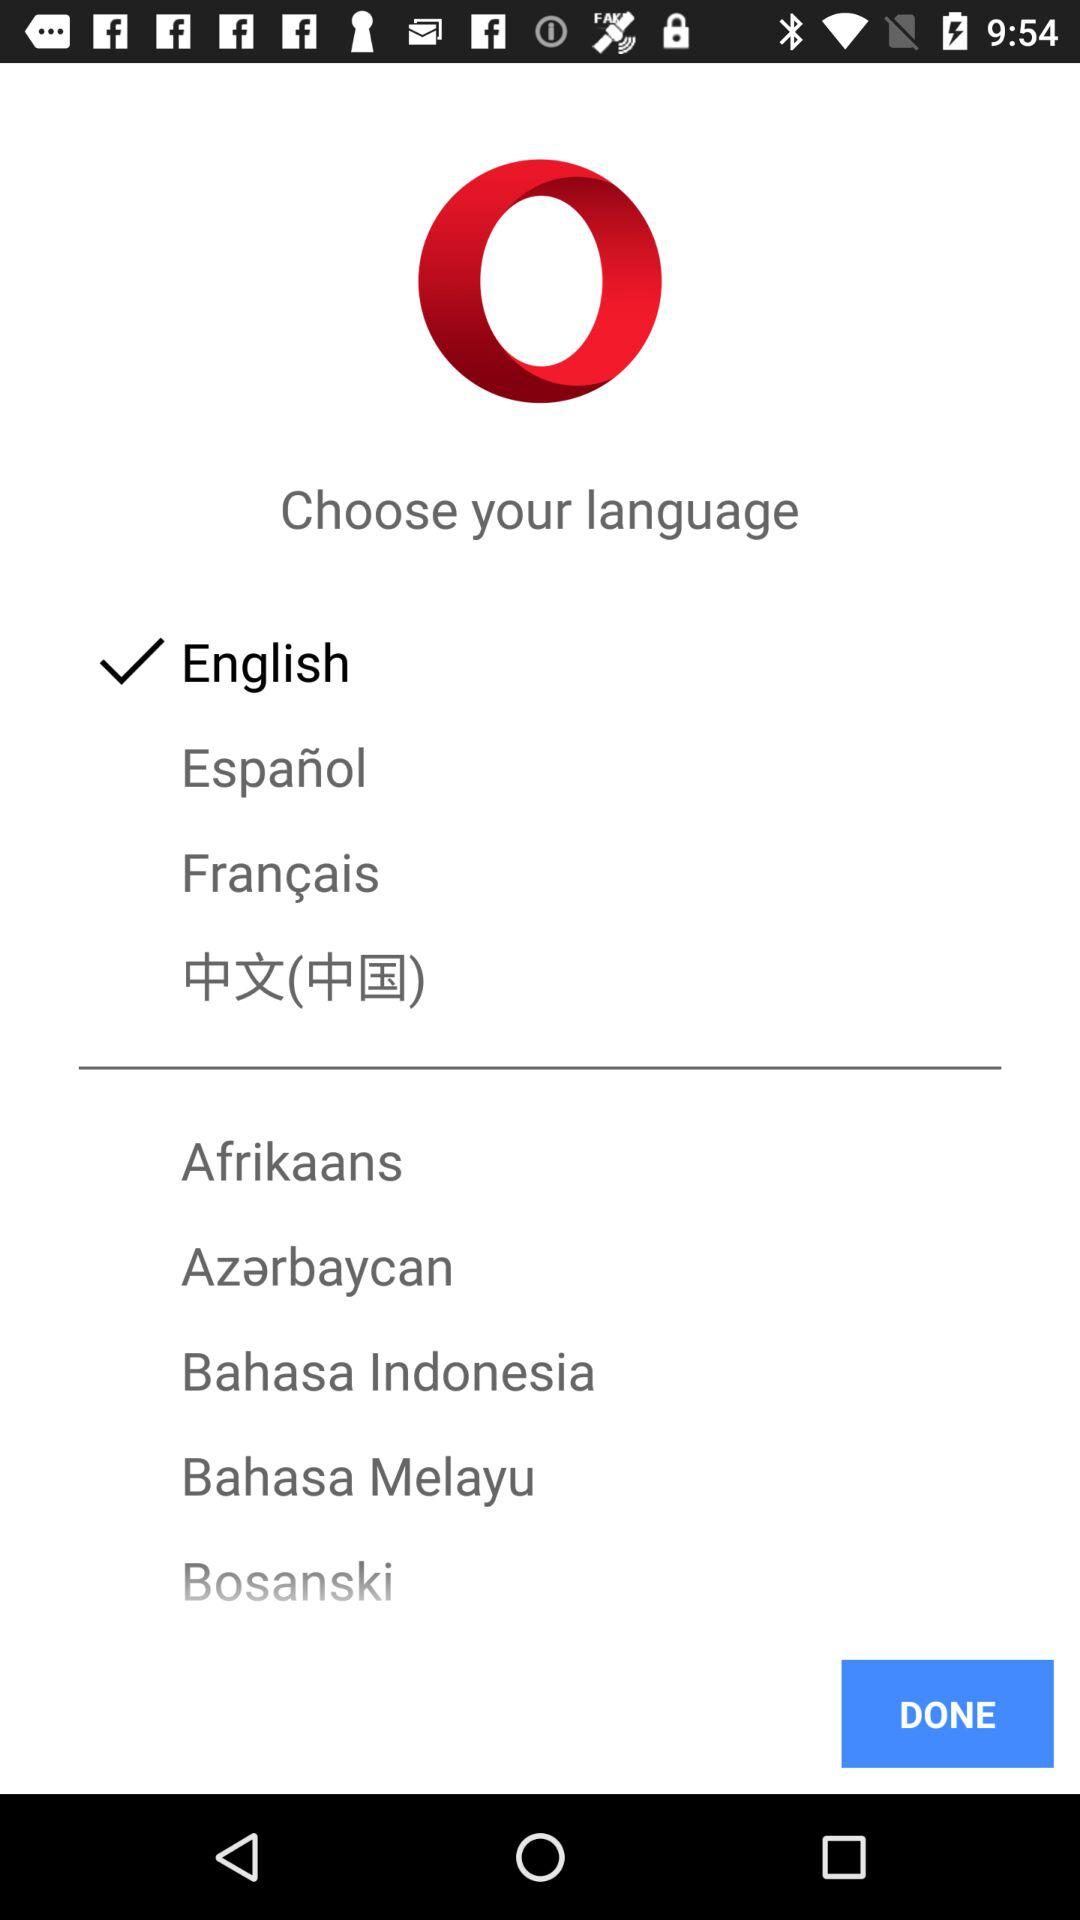What is the selected language? The selected language is English. 